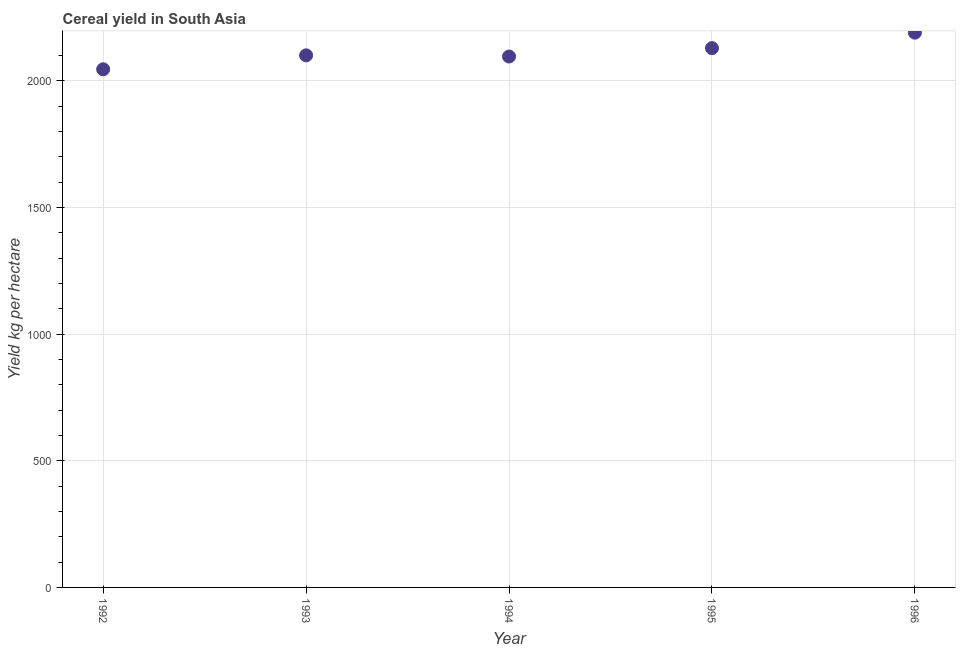What is the cereal yield in 1995?
Ensure brevity in your answer.  2128.66. Across all years, what is the maximum cereal yield?
Offer a very short reply. 2189.71. Across all years, what is the minimum cereal yield?
Provide a succinct answer. 2045.04. In which year was the cereal yield maximum?
Provide a succinct answer. 1996. What is the sum of the cereal yield?
Ensure brevity in your answer.  1.06e+04. What is the difference between the cereal yield in 1993 and 1996?
Make the answer very short. -89.51. What is the average cereal yield per year?
Your response must be concise. 2111.82. What is the median cereal yield?
Provide a short and direct response. 2100.19. What is the ratio of the cereal yield in 1993 to that in 1996?
Your answer should be very brief. 0.96. Is the difference between the cereal yield in 1995 and 1996 greater than the difference between any two years?
Provide a succinct answer. No. What is the difference between the highest and the second highest cereal yield?
Your answer should be compact. 61.05. What is the difference between the highest and the lowest cereal yield?
Make the answer very short. 144.67. What is the difference between two consecutive major ticks on the Y-axis?
Make the answer very short. 500. Are the values on the major ticks of Y-axis written in scientific E-notation?
Offer a very short reply. No. Does the graph contain grids?
Your response must be concise. Yes. What is the title of the graph?
Keep it short and to the point. Cereal yield in South Asia. What is the label or title of the X-axis?
Your response must be concise. Year. What is the label or title of the Y-axis?
Offer a very short reply. Yield kg per hectare. What is the Yield kg per hectare in 1992?
Give a very brief answer. 2045.04. What is the Yield kg per hectare in 1993?
Offer a very short reply. 2100.19. What is the Yield kg per hectare in 1994?
Your answer should be very brief. 2095.52. What is the Yield kg per hectare in 1995?
Your response must be concise. 2128.66. What is the Yield kg per hectare in 1996?
Provide a short and direct response. 2189.71. What is the difference between the Yield kg per hectare in 1992 and 1993?
Your answer should be compact. -55.16. What is the difference between the Yield kg per hectare in 1992 and 1994?
Your response must be concise. -50.48. What is the difference between the Yield kg per hectare in 1992 and 1995?
Provide a short and direct response. -83.63. What is the difference between the Yield kg per hectare in 1992 and 1996?
Your answer should be compact. -144.67. What is the difference between the Yield kg per hectare in 1993 and 1994?
Make the answer very short. 4.68. What is the difference between the Yield kg per hectare in 1993 and 1995?
Offer a terse response. -28.47. What is the difference between the Yield kg per hectare in 1993 and 1996?
Offer a terse response. -89.51. What is the difference between the Yield kg per hectare in 1994 and 1995?
Ensure brevity in your answer.  -33.15. What is the difference between the Yield kg per hectare in 1994 and 1996?
Make the answer very short. -94.19. What is the difference between the Yield kg per hectare in 1995 and 1996?
Offer a very short reply. -61.05. What is the ratio of the Yield kg per hectare in 1992 to that in 1993?
Offer a very short reply. 0.97. What is the ratio of the Yield kg per hectare in 1992 to that in 1994?
Your answer should be very brief. 0.98. What is the ratio of the Yield kg per hectare in 1992 to that in 1995?
Ensure brevity in your answer.  0.96. What is the ratio of the Yield kg per hectare in 1992 to that in 1996?
Provide a short and direct response. 0.93. What is the ratio of the Yield kg per hectare in 1993 to that in 1994?
Make the answer very short. 1. What is the ratio of the Yield kg per hectare in 1993 to that in 1995?
Offer a terse response. 0.99. What is the ratio of the Yield kg per hectare in 1994 to that in 1996?
Give a very brief answer. 0.96. 